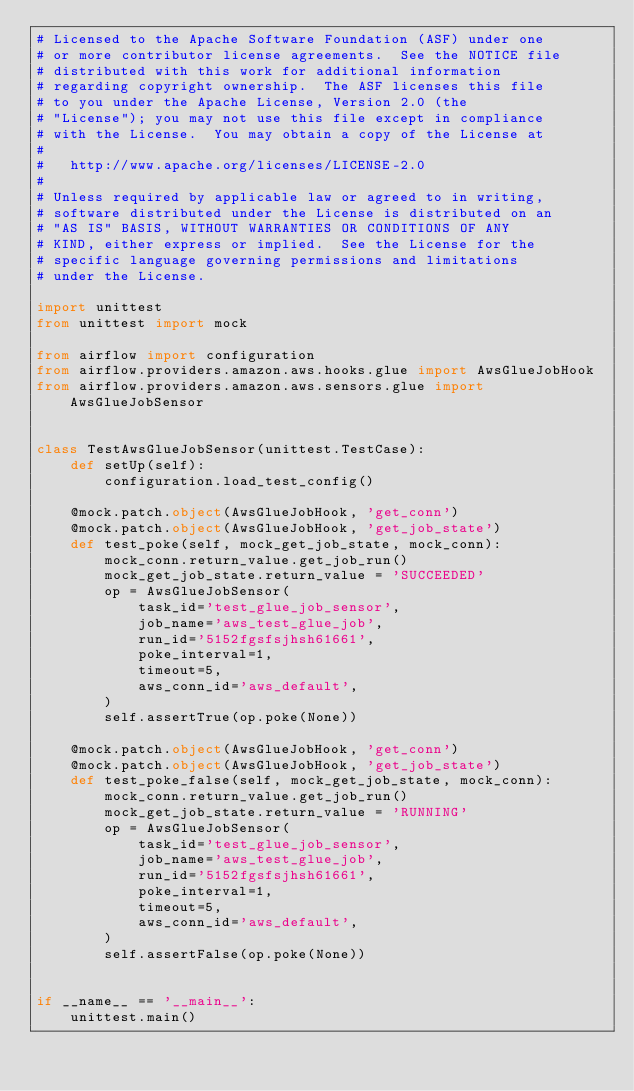<code> <loc_0><loc_0><loc_500><loc_500><_Python_># Licensed to the Apache Software Foundation (ASF) under one
# or more contributor license agreements.  See the NOTICE file
# distributed with this work for additional information
# regarding copyright ownership.  The ASF licenses this file
# to you under the Apache License, Version 2.0 (the
# "License"); you may not use this file except in compliance
# with the License.  You may obtain a copy of the License at
#
#   http://www.apache.org/licenses/LICENSE-2.0
#
# Unless required by applicable law or agreed to in writing,
# software distributed under the License is distributed on an
# "AS IS" BASIS, WITHOUT WARRANTIES OR CONDITIONS OF ANY
# KIND, either express or implied.  See the License for the
# specific language governing permissions and limitations
# under the License.

import unittest
from unittest import mock

from airflow import configuration
from airflow.providers.amazon.aws.hooks.glue import AwsGlueJobHook
from airflow.providers.amazon.aws.sensors.glue import AwsGlueJobSensor


class TestAwsGlueJobSensor(unittest.TestCase):
    def setUp(self):
        configuration.load_test_config()

    @mock.patch.object(AwsGlueJobHook, 'get_conn')
    @mock.patch.object(AwsGlueJobHook, 'get_job_state')
    def test_poke(self, mock_get_job_state, mock_conn):
        mock_conn.return_value.get_job_run()
        mock_get_job_state.return_value = 'SUCCEEDED'
        op = AwsGlueJobSensor(
            task_id='test_glue_job_sensor',
            job_name='aws_test_glue_job',
            run_id='5152fgsfsjhsh61661',
            poke_interval=1,
            timeout=5,
            aws_conn_id='aws_default',
        )
        self.assertTrue(op.poke(None))

    @mock.patch.object(AwsGlueJobHook, 'get_conn')
    @mock.patch.object(AwsGlueJobHook, 'get_job_state')
    def test_poke_false(self, mock_get_job_state, mock_conn):
        mock_conn.return_value.get_job_run()
        mock_get_job_state.return_value = 'RUNNING'
        op = AwsGlueJobSensor(
            task_id='test_glue_job_sensor',
            job_name='aws_test_glue_job',
            run_id='5152fgsfsjhsh61661',
            poke_interval=1,
            timeout=5,
            aws_conn_id='aws_default',
        )
        self.assertFalse(op.poke(None))


if __name__ == '__main__':
    unittest.main()
</code> 